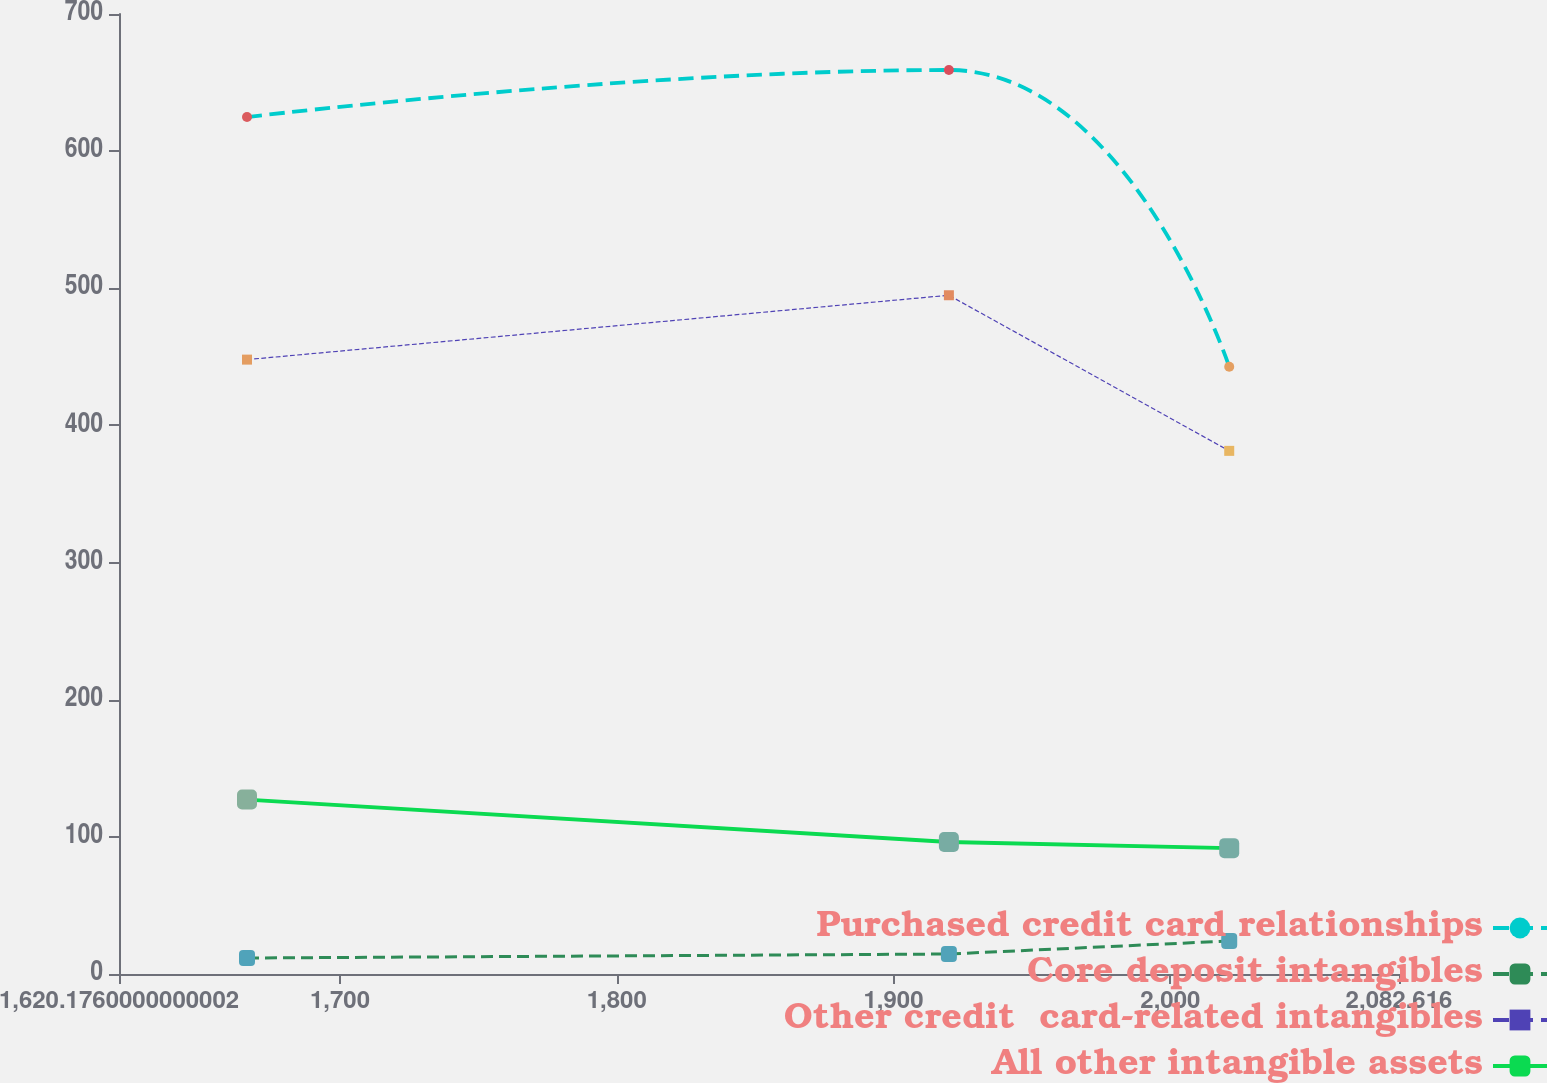Convert chart to OTSL. <chart><loc_0><loc_0><loc_500><loc_500><line_chart><ecel><fcel>Purchased credit card relationships<fcel>Core deposit intangibles<fcel>Other credit  card-related intangibles<fcel>All other intangible assets<nl><fcel>1666.42<fcel>624.86<fcel>11.66<fcel>447.99<fcel>127.22<nl><fcel>1920<fcel>659.17<fcel>14.57<fcel>494.92<fcel>96.24<nl><fcel>2021.28<fcel>442.8<fcel>24.08<fcel>381.46<fcel>91.76<nl><fcel>2083.44<fcel>341.8<fcel>26.49<fcel>359.67<fcel>86.87<nl><fcel>2128.86<fcel>287.62<fcel>35.27<fcel>314.58<fcel>82.39<nl></chart> 